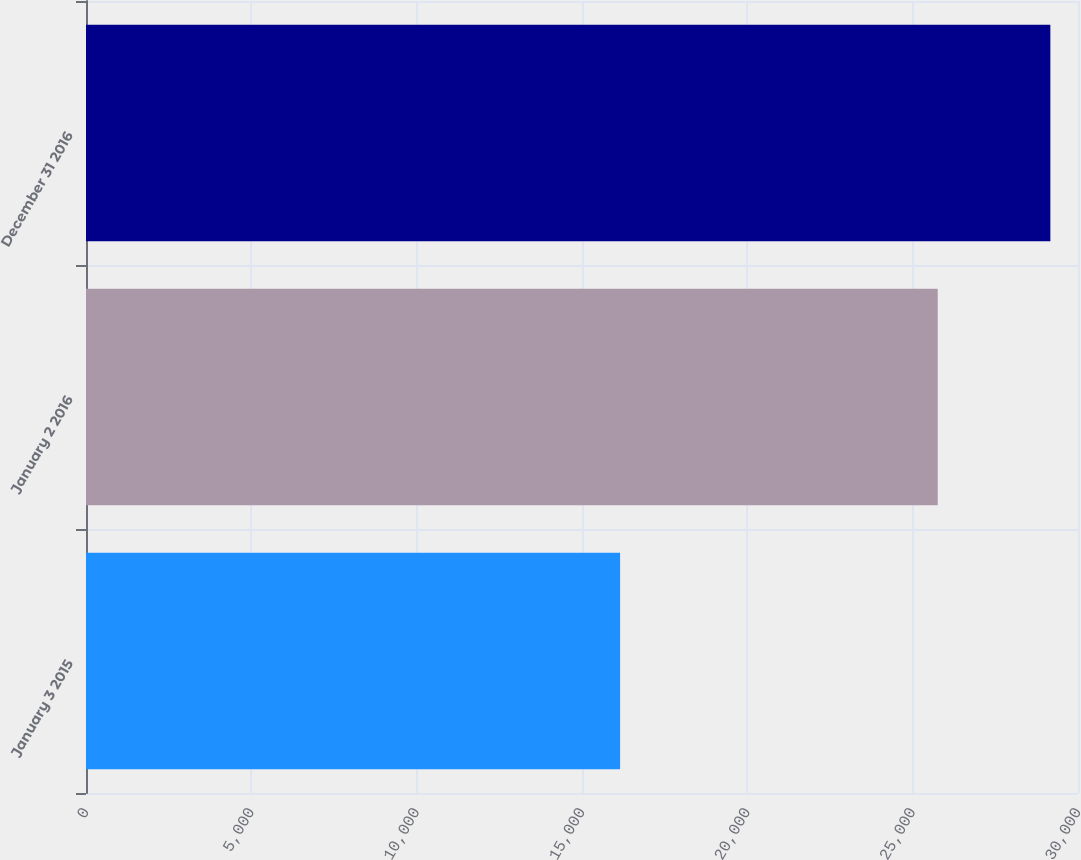Convert chart. <chart><loc_0><loc_0><loc_500><loc_500><bar_chart><fcel>January 3 2015<fcel>January 2 2016<fcel>December 31 2016<nl><fcel>16152<fcel>25758<fcel>29164<nl></chart> 